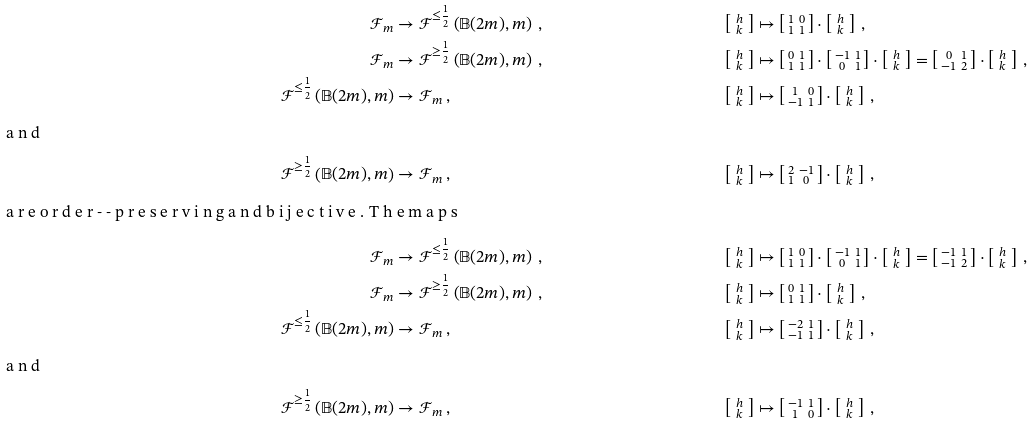<formula> <loc_0><loc_0><loc_500><loc_500>\mathcal { F } _ { m } & \to \mathcal { F } ^ { \leq \frac { 1 } { 2 } } \left ( \mathbb { B } ( 2 m ) , m \right ) \, , & \left [ \begin{smallmatrix} \, h \, \\ \, k \, \end{smallmatrix} \right ] & \mapsto \left [ \begin{smallmatrix} 1 & 0 \\ 1 & 1 \end{smallmatrix} \right ] \cdot \left [ \begin{smallmatrix} \, h \, \\ \, k \, \end{smallmatrix} \right ] \, , \\ \mathcal { F } _ { m } & \to \mathcal { F } ^ { \geq \frac { 1 } { 2 } } \left ( \mathbb { B } ( 2 m ) , m \right ) \, , & \left [ \begin{smallmatrix} \, h \, \\ \, k \, \end{smallmatrix} \right ] & \mapsto \left [ \begin{smallmatrix} 0 & 1 \\ 1 & 1 \end{smallmatrix} \right ] \cdot \left [ \begin{smallmatrix} - 1 & 1 \\ 0 & 1 \end{smallmatrix} \right ] \cdot \left [ \begin{smallmatrix} \, h \, \\ \, k \, \end{smallmatrix} \right ] = \left [ \begin{smallmatrix} 0 & 1 \\ - 1 & 2 \end{smallmatrix} \right ] \cdot \left [ \begin{smallmatrix} \, h \, \\ \, k \, \end{smallmatrix} \right ] \, , \\ \mathcal { F } ^ { \leq \frac { 1 } { 2 } } \left ( \mathbb { B } ( 2 m ) , m \right ) & \to \mathcal { F } _ { m } \, , & \left [ \begin{smallmatrix} \, h \, \\ \, k \, \end{smallmatrix} \right ] & \mapsto \left [ \begin{smallmatrix} 1 & 0 \\ - 1 & 1 \end{smallmatrix} \right ] \cdot \left [ \begin{smallmatrix} \, h \, \\ \, k \, \end{smallmatrix} \right ] \, , \\ \intertext { a n d } \mathcal { F } ^ { \geq \frac { 1 } { 2 } } \left ( \mathbb { B } ( 2 m ) , m \right ) & \to \mathcal { F } _ { m } \, , & \left [ \begin{smallmatrix} \, h \, \\ \, k \, \end{smallmatrix} \right ] & \mapsto \left [ \begin{smallmatrix} 2 & - 1 \\ 1 & 0 \end{smallmatrix} \right ] \cdot \left [ \begin{smallmatrix} \, h \, \\ \, k \, \end{smallmatrix} \right ] \, , \intertext { a r e o r d e r - - p r e s e r v i n g a n d b i j e c t i v e . T h e m a p s } \mathcal { F } _ { m } & \to \mathcal { F } ^ { \leq \frac { 1 } { 2 } } \left ( \mathbb { B } ( 2 m ) , m \right ) \, , & \left [ \begin{smallmatrix} \, h \, \\ \, k \, \end{smallmatrix} \right ] & \mapsto \left [ \begin{smallmatrix} 1 & 0 \\ 1 & 1 \end{smallmatrix} \right ] \cdot \left [ \begin{smallmatrix} - 1 & 1 \\ 0 & 1 \end{smallmatrix} \right ] \cdot \left [ \begin{smallmatrix} \, h \, \\ \, k \, \end{smallmatrix} \right ] = \left [ \begin{smallmatrix} - 1 & 1 \\ - 1 & 2 \end{smallmatrix} \right ] \cdot \left [ \begin{smallmatrix} \, h \, \\ \, k \, \end{smallmatrix} \right ] \, , \\ \mathcal { F } _ { m } & \to \mathcal { F } ^ { \geq \frac { 1 } { 2 } } \left ( \mathbb { B } ( 2 m ) , m \right ) \, , & \left [ \begin{smallmatrix} \, h \, \\ \, k \, \end{smallmatrix} \right ] & \mapsto \left [ \begin{smallmatrix} 0 & 1 \\ 1 & 1 \end{smallmatrix} \right ] \cdot \left [ \begin{smallmatrix} \, h \, \\ \, k \, \end{smallmatrix} \right ] \, , \\ \mathcal { F } ^ { \leq \frac { 1 } { 2 } } \left ( \mathbb { B } ( 2 m ) , m \right ) & \to \mathcal { F } _ { m } \, , & \left [ \begin{smallmatrix} \, h \, \\ \, k \, \end{smallmatrix} \right ] & \mapsto \left [ \begin{smallmatrix} - 2 & 1 \\ - 1 & 1 \end{smallmatrix} \right ] \cdot \left [ \begin{smallmatrix} \, h \, \\ \, k \, \end{smallmatrix} \right ] \, , \\ \intertext { a n d } \mathcal { F } ^ { \geq \frac { 1 } { 2 } } \left ( \mathbb { B } ( 2 m ) , m \right ) & \to \mathcal { F } _ { m } \, , & \left [ \begin{smallmatrix} \, h \, \\ \, k \, \end{smallmatrix} \right ] & \mapsto \left [ \begin{smallmatrix} - 1 & 1 \\ 1 & 0 \end{smallmatrix} \right ] \cdot \left [ \begin{smallmatrix} \, h \, \\ \, k \, \end{smallmatrix} \right ] \, ,</formula> 